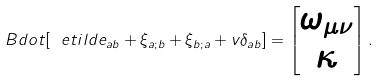Convert formula to latex. <formula><loc_0><loc_0><loc_500><loc_500>\ B d o t [ \ e t i l d e _ { a b } + \xi _ { a ; b } + \xi _ { b ; a } + v \delta _ { a b } ] = \begin{bmatrix} \omega _ { \mu \nu } \\ \kappa \end{bmatrix} .</formula> 